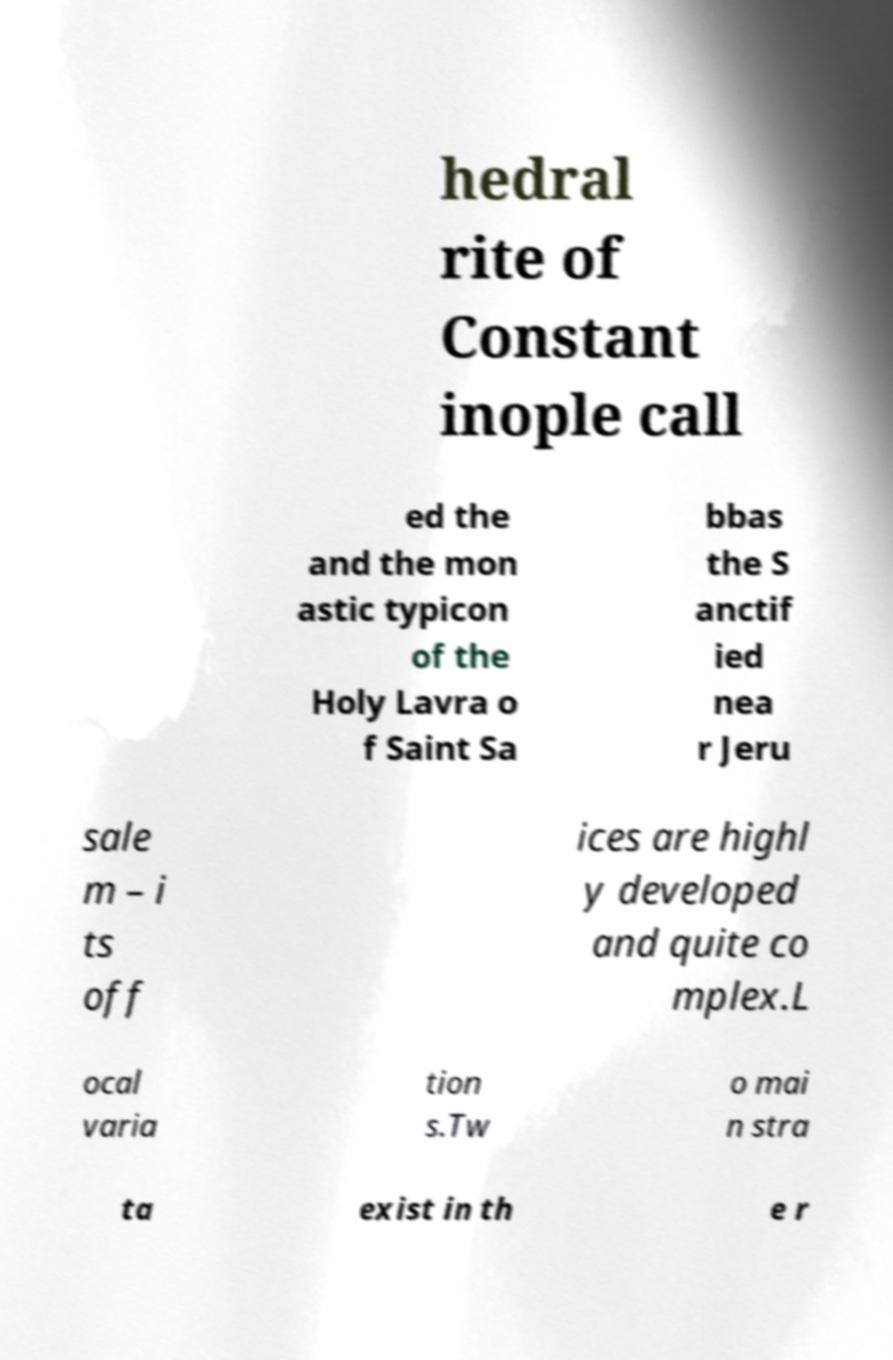I need the written content from this picture converted into text. Can you do that? hedral rite of Constant inople call ed the and the mon astic typicon of the Holy Lavra o f Saint Sa bbas the S anctif ied nea r Jeru sale m – i ts off ices are highl y developed and quite co mplex.L ocal varia tion s.Tw o mai n stra ta exist in th e r 